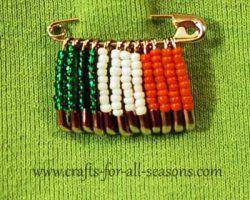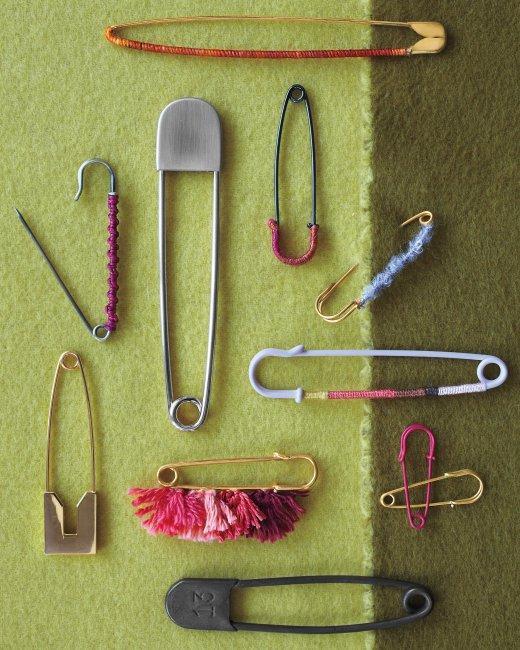The first image is the image on the left, the second image is the image on the right. For the images shown, is this caption "There is one open safety pin." true? Answer yes or no. Yes. The first image is the image on the left, the second image is the image on the right. Given the left and right images, does the statement "In one image a safety pin is open." hold true? Answer yes or no. Yes. 